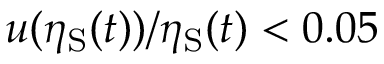<formula> <loc_0><loc_0><loc_500><loc_500>u ( \eta _ { S } ( t ) ) / \eta _ { S } ( t ) < 0 . 0 5</formula> 